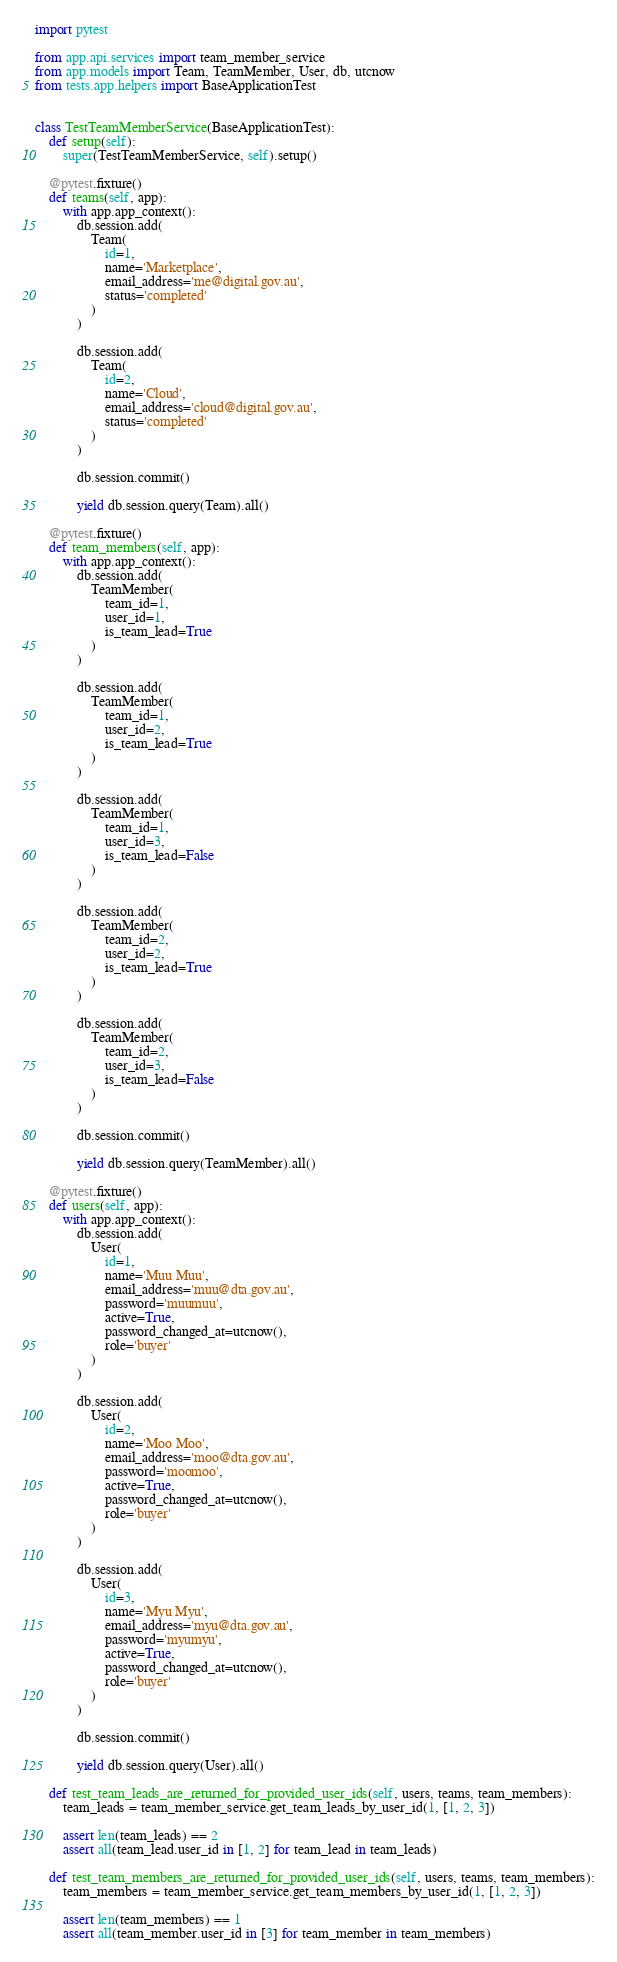Convert code to text. <code><loc_0><loc_0><loc_500><loc_500><_Python_>import pytest

from app.api.services import team_member_service
from app.models import Team, TeamMember, User, db, utcnow
from tests.app.helpers import BaseApplicationTest


class TestTeamMemberService(BaseApplicationTest):
    def setup(self):
        super(TestTeamMemberService, self).setup()

    @pytest.fixture()
    def teams(self, app):
        with app.app_context():
            db.session.add(
                Team(
                    id=1,
                    name='Marketplace',
                    email_address='me@digital.gov.au',
                    status='completed'
                )
            )

            db.session.add(
                Team(
                    id=2,
                    name='Cloud',
                    email_address='cloud@digital.gov.au',
                    status='completed'
                )
            )

            db.session.commit()

            yield db.session.query(Team).all()

    @pytest.fixture()
    def team_members(self, app):
        with app.app_context():
            db.session.add(
                TeamMember(
                    team_id=1,
                    user_id=1,
                    is_team_lead=True
                )
            )

            db.session.add(
                TeamMember(
                    team_id=1,
                    user_id=2,
                    is_team_lead=True
                )
            )

            db.session.add(
                TeamMember(
                    team_id=1,
                    user_id=3,
                    is_team_lead=False
                )
            )

            db.session.add(
                TeamMember(
                    team_id=2,
                    user_id=2,
                    is_team_lead=True
                )
            )

            db.session.add(
                TeamMember(
                    team_id=2,
                    user_id=3,
                    is_team_lead=False
                )
            )

            db.session.commit()

            yield db.session.query(TeamMember).all()

    @pytest.fixture()
    def users(self, app):
        with app.app_context():
            db.session.add(
                User(
                    id=1,
                    name='Muu Muu',
                    email_address='muu@dta.gov.au',
                    password='muumuu',
                    active=True,
                    password_changed_at=utcnow(),
                    role='buyer'
                )
            )

            db.session.add(
                User(
                    id=2,
                    name='Moo Moo',
                    email_address='moo@dta.gov.au',
                    password='moomoo',
                    active=True,
                    password_changed_at=utcnow(),
                    role='buyer'
                )
            )

            db.session.add(
                User(
                    id=3,
                    name='Myu Myu',
                    email_address='myu@dta.gov.au',
                    password='myumyu',
                    active=True,
                    password_changed_at=utcnow(),
                    role='buyer'
                )
            )

            db.session.commit()

            yield db.session.query(User).all()

    def test_team_leads_are_returned_for_provided_user_ids(self, users, teams, team_members):
        team_leads = team_member_service.get_team_leads_by_user_id(1, [1, 2, 3])

        assert len(team_leads) == 2
        assert all(team_lead.user_id in [1, 2] for team_lead in team_leads)

    def test_team_members_are_returned_for_provided_user_ids(self, users, teams, team_members):
        team_members = team_member_service.get_team_members_by_user_id(1, [1, 2, 3])

        assert len(team_members) == 1
        assert all(team_member.user_id in [3] for team_member in team_members)
</code> 